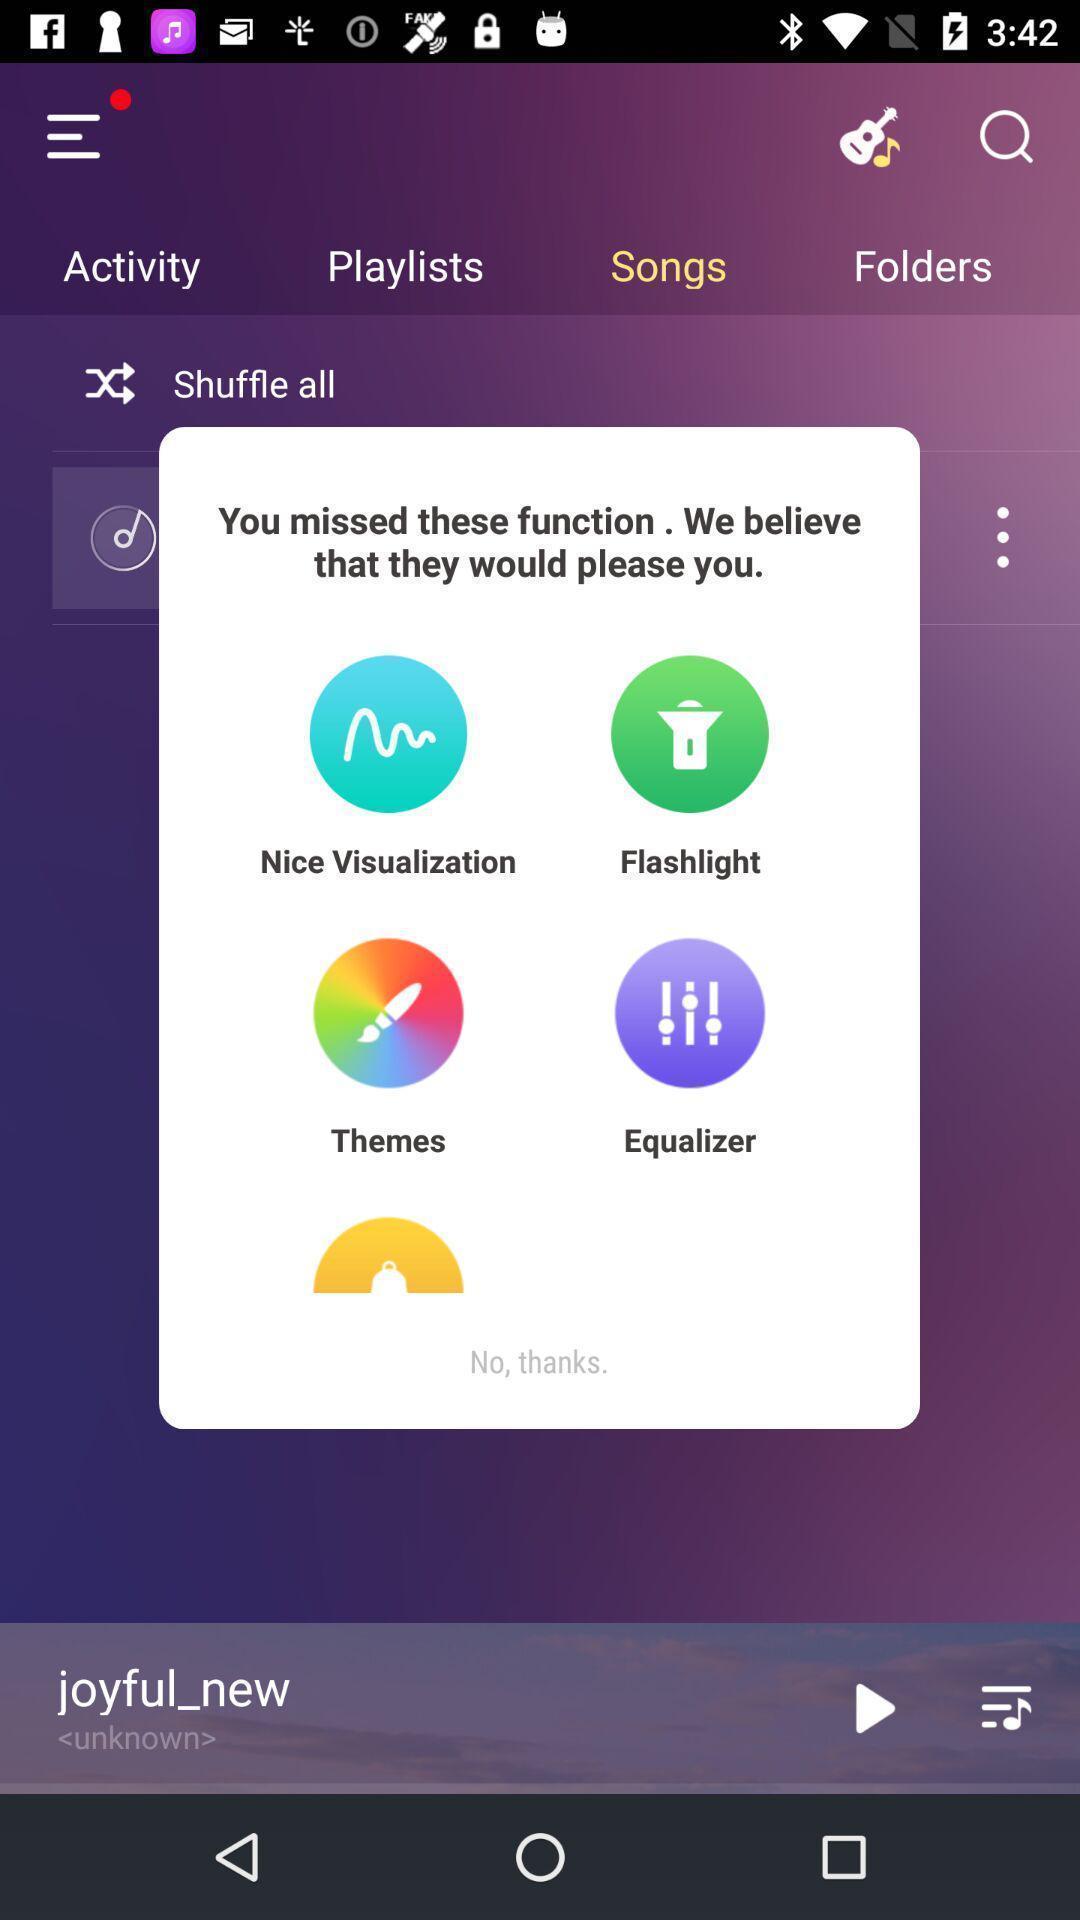Provide a textual representation of this image. Pop-up showing the functions which are missed. 